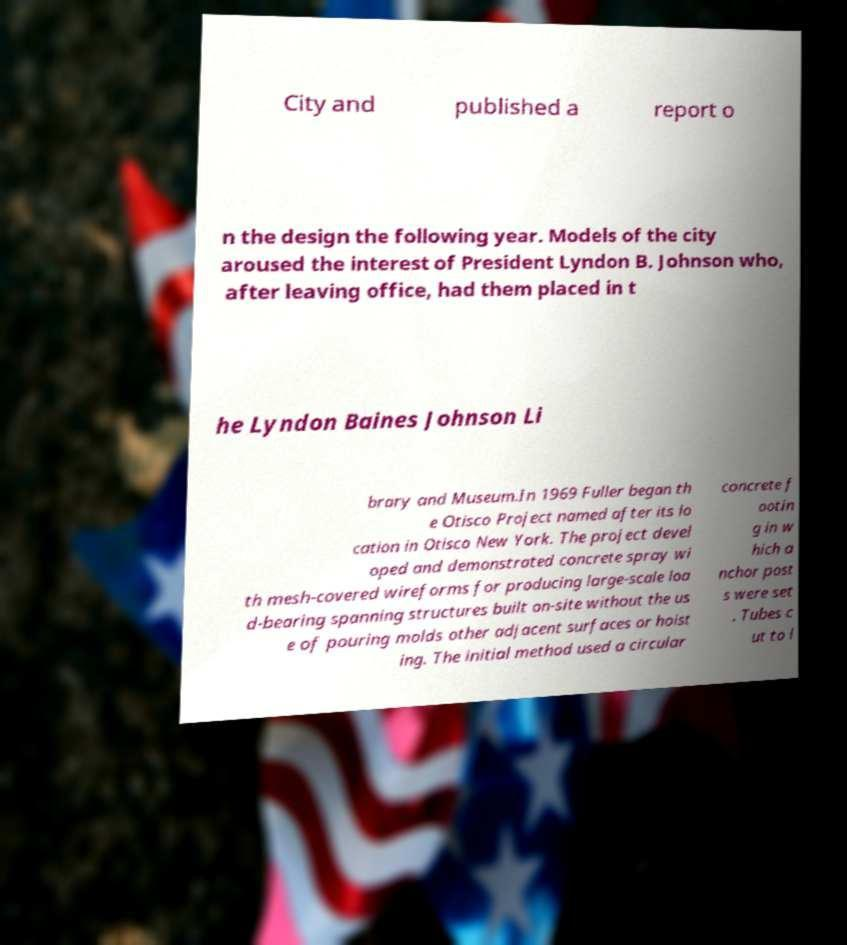I need the written content from this picture converted into text. Can you do that? City and published a report o n the design the following year. Models of the city aroused the interest of President Lyndon B. Johnson who, after leaving office, had them placed in t he Lyndon Baines Johnson Li brary and Museum.In 1969 Fuller began th e Otisco Project named after its lo cation in Otisco New York. The project devel oped and demonstrated concrete spray wi th mesh-covered wireforms for producing large-scale loa d-bearing spanning structures built on-site without the us e of pouring molds other adjacent surfaces or hoist ing. The initial method used a circular concrete f ootin g in w hich a nchor post s were set . Tubes c ut to l 